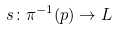<formula> <loc_0><loc_0><loc_500><loc_500>s \colon \pi ^ { - 1 } ( p ) \to \L L</formula> 